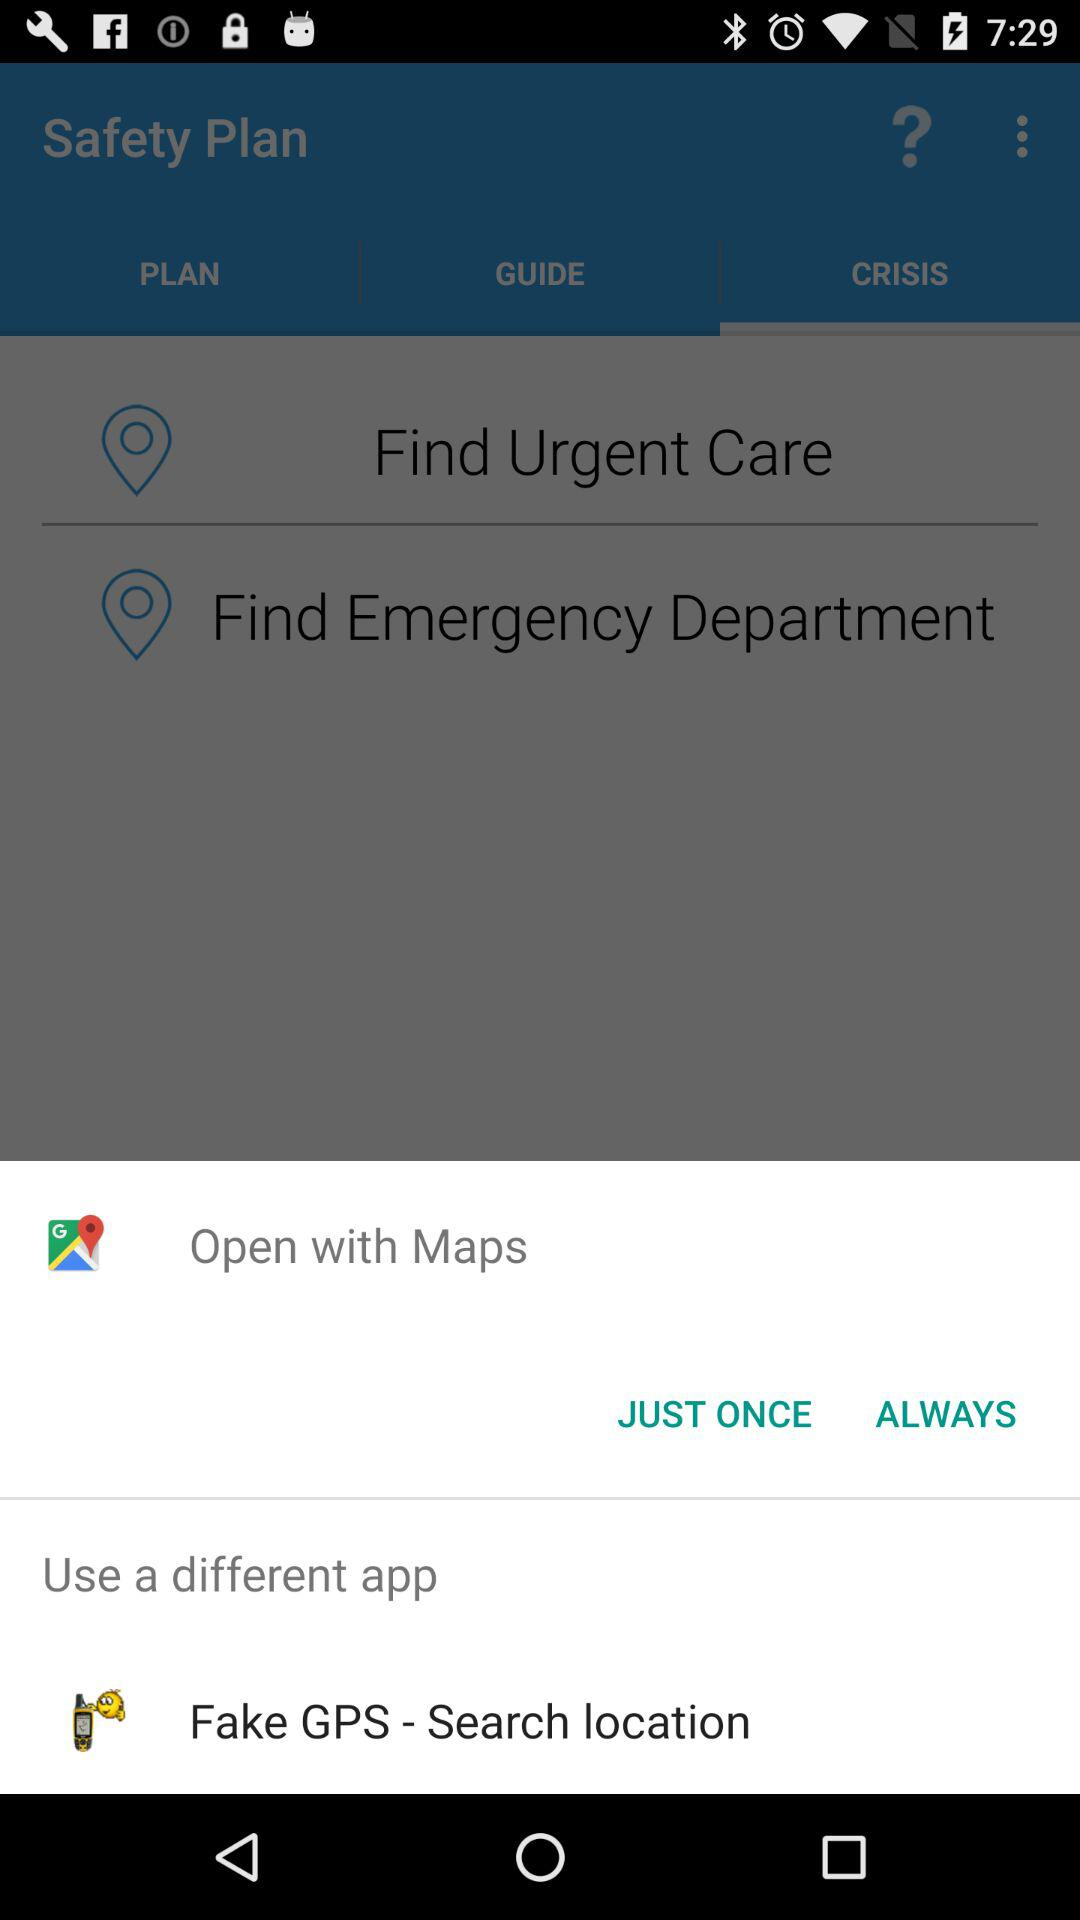Which application can we use to open it? The applications that you can use to open are "Maps" and "Fake GPS - Search location". 